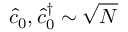<formula> <loc_0><loc_0><loc_500><loc_500>\hat { c } _ { 0 } , \hat { c } _ { 0 } ^ { \dag } \sim \sqrt { N }</formula> 